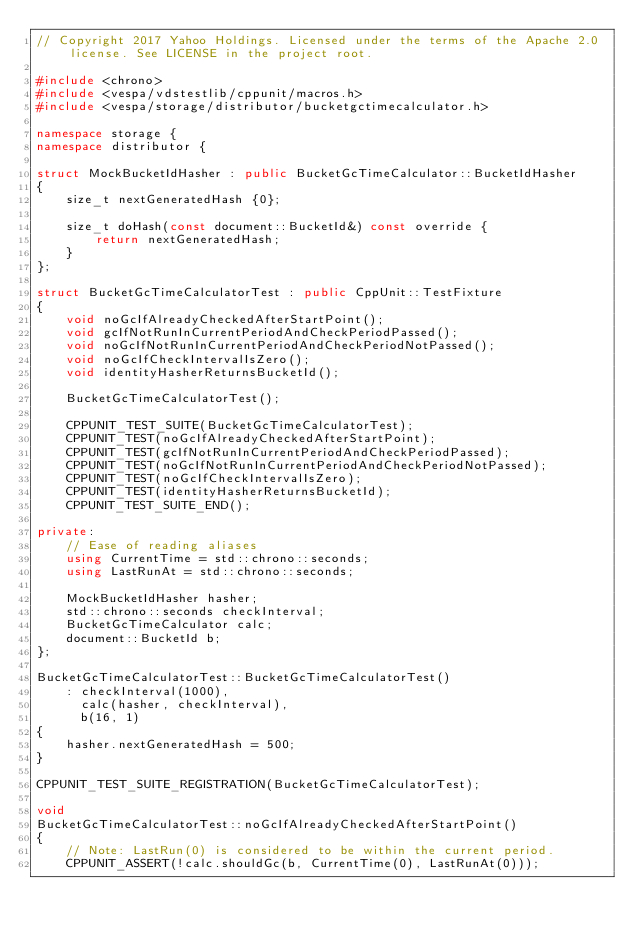Convert code to text. <code><loc_0><loc_0><loc_500><loc_500><_C++_>// Copyright 2017 Yahoo Holdings. Licensed under the terms of the Apache 2.0 license. See LICENSE in the project root.

#include <chrono>
#include <vespa/vdstestlib/cppunit/macros.h>
#include <vespa/storage/distributor/bucketgctimecalculator.h>

namespace storage {
namespace distributor {

struct MockBucketIdHasher : public BucketGcTimeCalculator::BucketIdHasher
{
    size_t nextGeneratedHash {0};

    size_t doHash(const document::BucketId&) const override {
        return nextGeneratedHash;
    }
};

struct BucketGcTimeCalculatorTest : public CppUnit::TestFixture
{
    void noGcIfAlreadyCheckedAfterStartPoint();
    void gcIfNotRunInCurrentPeriodAndCheckPeriodPassed();
    void noGcIfNotRunInCurrentPeriodAndCheckPeriodNotPassed();
    void noGcIfCheckIntervalIsZero();
    void identityHasherReturnsBucketId();

    BucketGcTimeCalculatorTest();

    CPPUNIT_TEST_SUITE(BucketGcTimeCalculatorTest);
    CPPUNIT_TEST(noGcIfAlreadyCheckedAfterStartPoint);
    CPPUNIT_TEST(gcIfNotRunInCurrentPeriodAndCheckPeriodPassed);
    CPPUNIT_TEST(noGcIfNotRunInCurrentPeriodAndCheckPeriodNotPassed);
    CPPUNIT_TEST(noGcIfCheckIntervalIsZero);
    CPPUNIT_TEST(identityHasherReturnsBucketId);
    CPPUNIT_TEST_SUITE_END();

private:
    // Ease of reading aliases
    using CurrentTime = std::chrono::seconds;
    using LastRunAt = std::chrono::seconds;

    MockBucketIdHasher hasher;
    std::chrono::seconds checkInterval;
    BucketGcTimeCalculator calc;
    document::BucketId b;
};

BucketGcTimeCalculatorTest::BucketGcTimeCalculatorTest()
    : checkInterval(1000),
      calc(hasher, checkInterval),
      b(16, 1)
{
    hasher.nextGeneratedHash = 500;
}

CPPUNIT_TEST_SUITE_REGISTRATION(BucketGcTimeCalculatorTest);

void
BucketGcTimeCalculatorTest::noGcIfAlreadyCheckedAfterStartPoint()
{
    // Note: LastRun(0) is considered to be within the current period.
    CPPUNIT_ASSERT(!calc.shouldGc(b, CurrentTime(0), LastRunAt(0)));</code> 